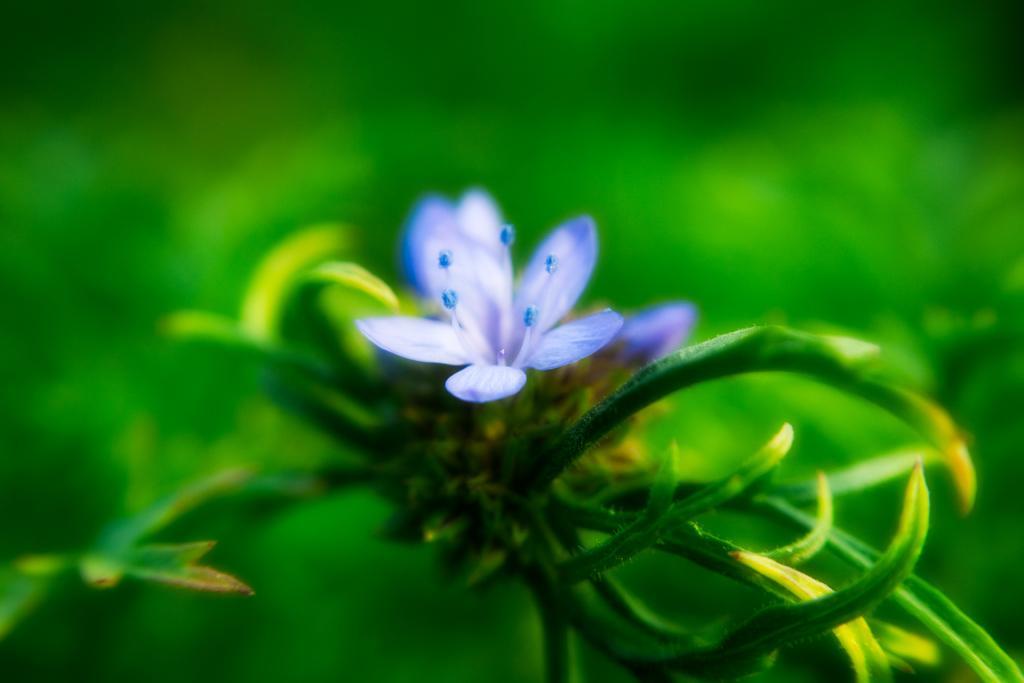Can you describe this image briefly? In this image I can see blue colour flower and green leaves. I can also see green colour in background and I can see this image is blurry from background. 